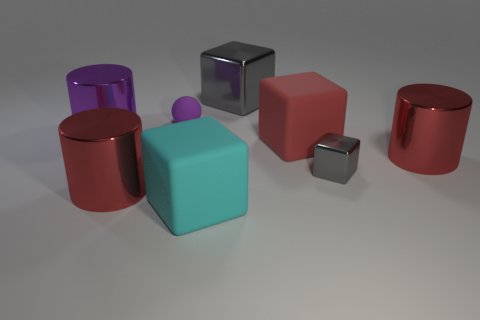Subtract all gray cubes. How many cubes are left? 2 Add 1 cyan shiny cylinders. How many objects exist? 9 Subtract all big red metal cylinders. How many cylinders are left? 1 Subtract all balls. How many objects are left? 7 Subtract all green spheres. How many purple cylinders are left? 1 Subtract all gray things. Subtract all big blue cylinders. How many objects are left? 6 Add 7 large cylinders. How many large cylinders are left? 10 Add 8 red cubes. How many red cubes exist? 9 Subtract 0 blue cubes. How many objects are left? 8 Subtract 1 cylinders. How many cylinders are left? 2 